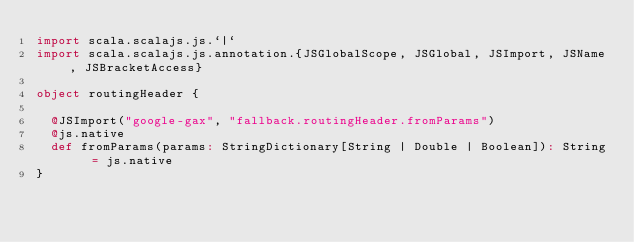<code> <loc_0><loc_0><loc_500><loc_500><_Scala_>import scala.scalajs.js.`|`
import scala.scalajs.js.annotation.{JSGlobalScope, JSGlobal, JSImport, JSName, JSBracketAccess}

object routingHeader {
  
  @JSImport("google-gax", "fallback.routingHeader.fromParams")
  @js.native
  def fromParams(params: StringDictionary[String | Double | Boolean]): String = js.native
}
</code> 